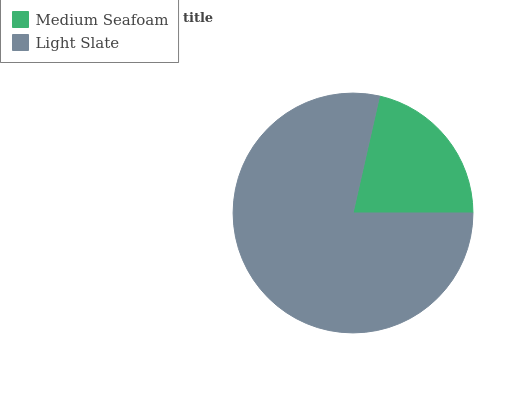Is Medium Seafoam the minimum?
Answer yes or no. Yes. Is Light Slate the maximum?
Answer yes or no. Yes. Is Light Slate the minimum?
Answer yes or no. No. Is Light Slate greater than Medium Seafoam?
Answer yes or no. Yes. Is Medium Seafoam less than Light Slate?
Answer yes or no. Yes. Is Medium Seafoam greater than Light Slate?
Answer yes or no. No. Is Light Slate less than Medium Seafoam?
Answer yes or no. No. Is Light Slate the high median?
Answer yes or no. Yes. Is Medium Seafoam the low median?
Answer yes or no. Yes. Is Medium Seafoam the high median?
Answer yes or no. No. Is Light Slate the low median?
Answer yes or no. No. 